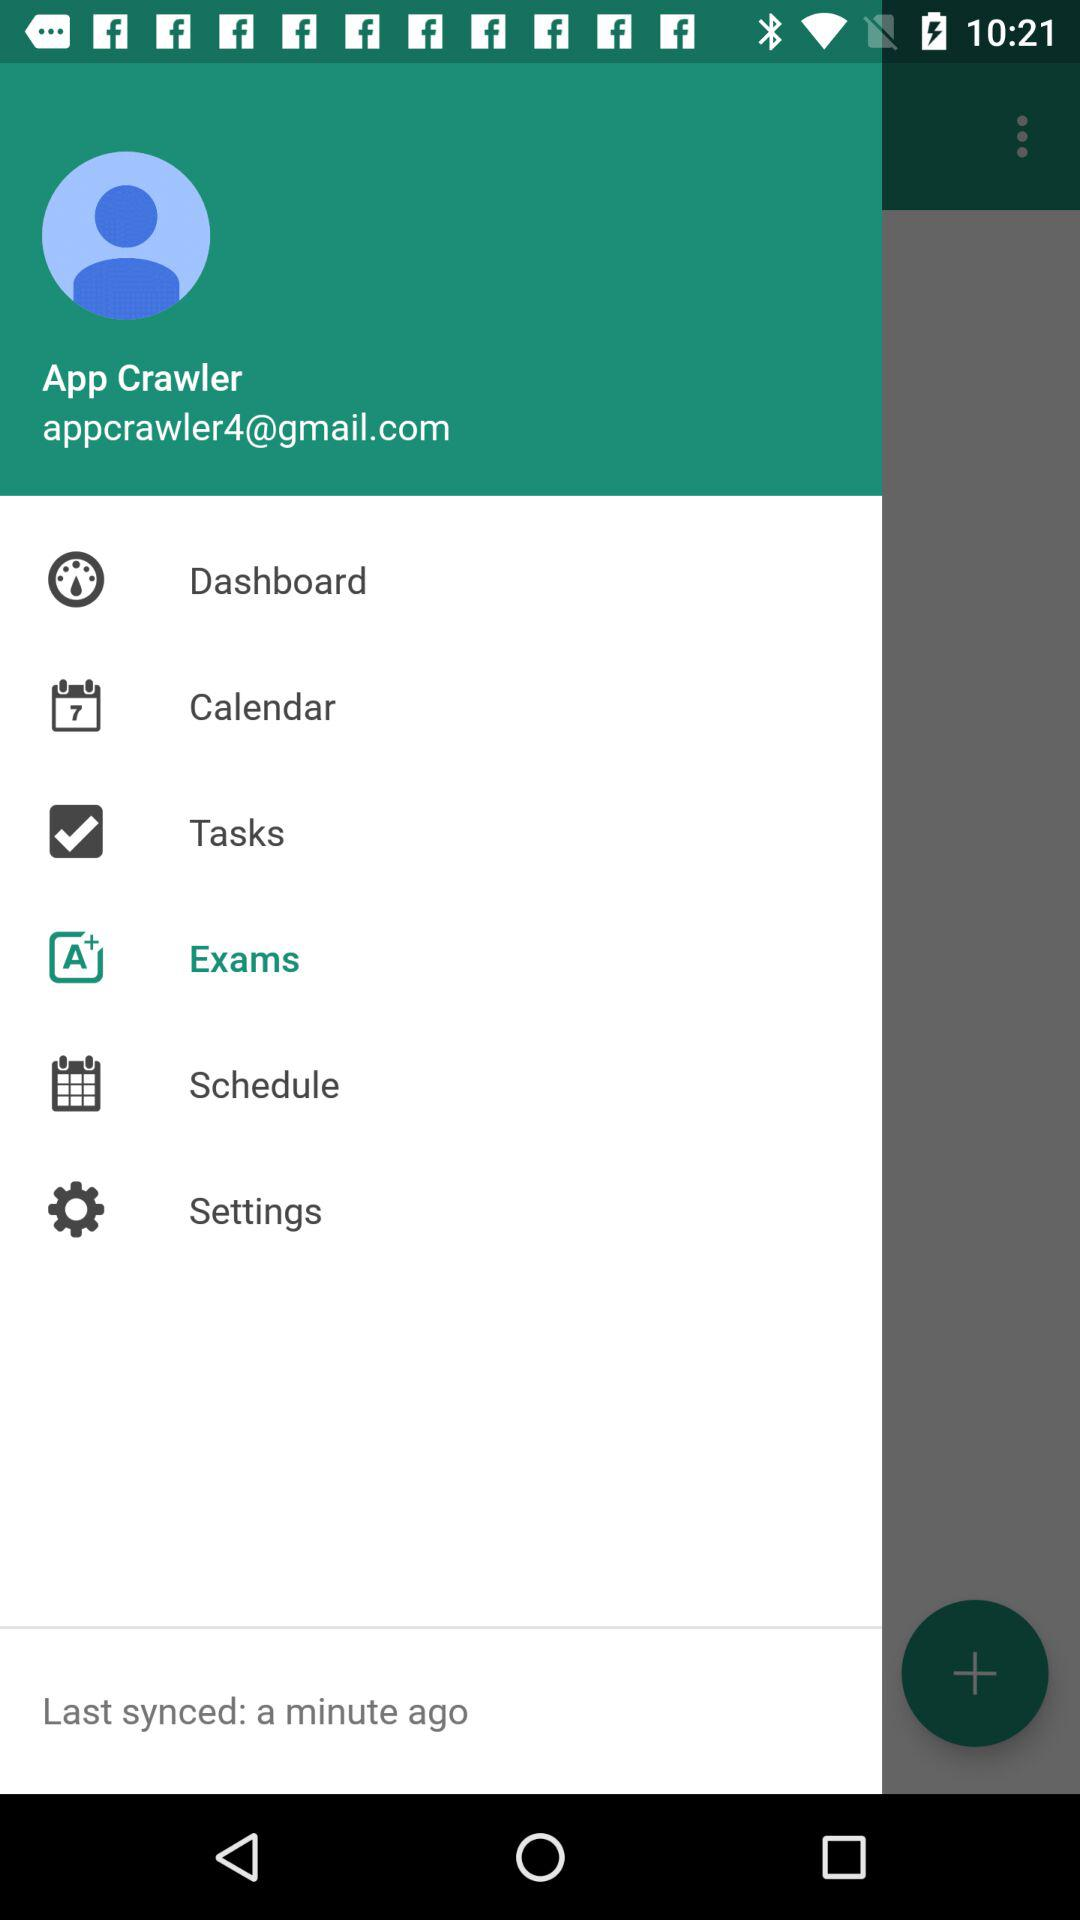What option is selected? The selected option is "Exams". 